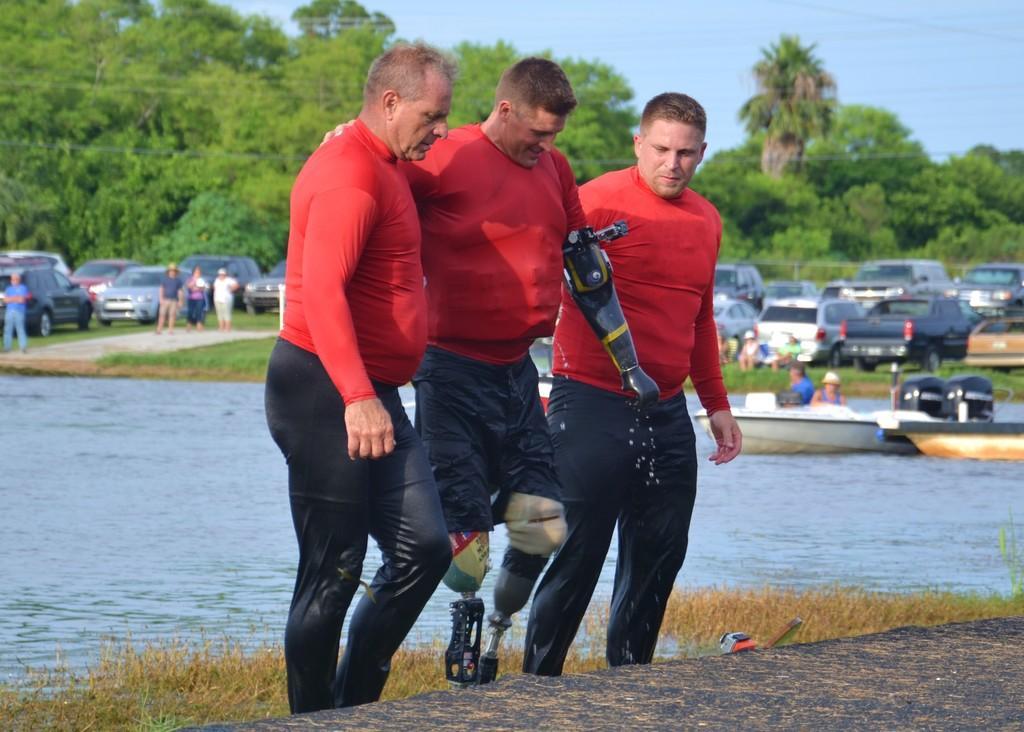Please provide a concise description of this image. In this image in the center there are persons. Behind the person there is water and on the ground there is grass. In the background there are persons standing and there are cars, there are trees and on the water there are boats with the persons inside it. 